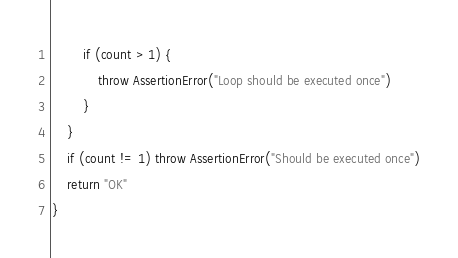<code> <loc_0><loc_0><loc_500><loc_500><_Kotlin_>        if (count > 1) {
            throw AssertionError("Loop should be executed once")
        }
    }
    if (count != 1) throw AssertionError("Should be executed once")
    return "OK"
}</code> 